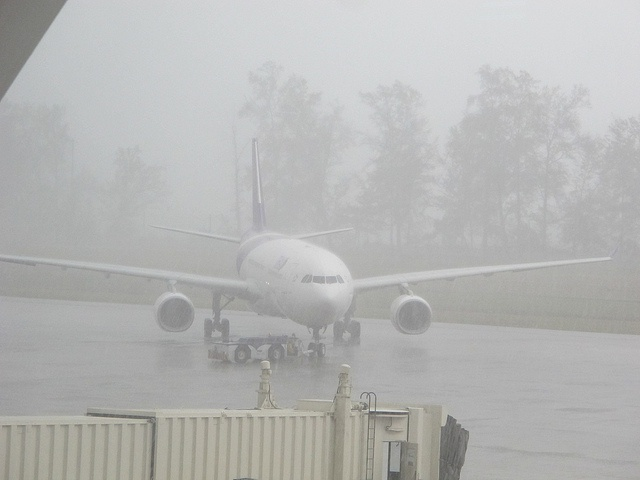Describe the objects in this image and their specific colors. I can see a airplane in gray, darkgray, and lightgray tones in this image. 